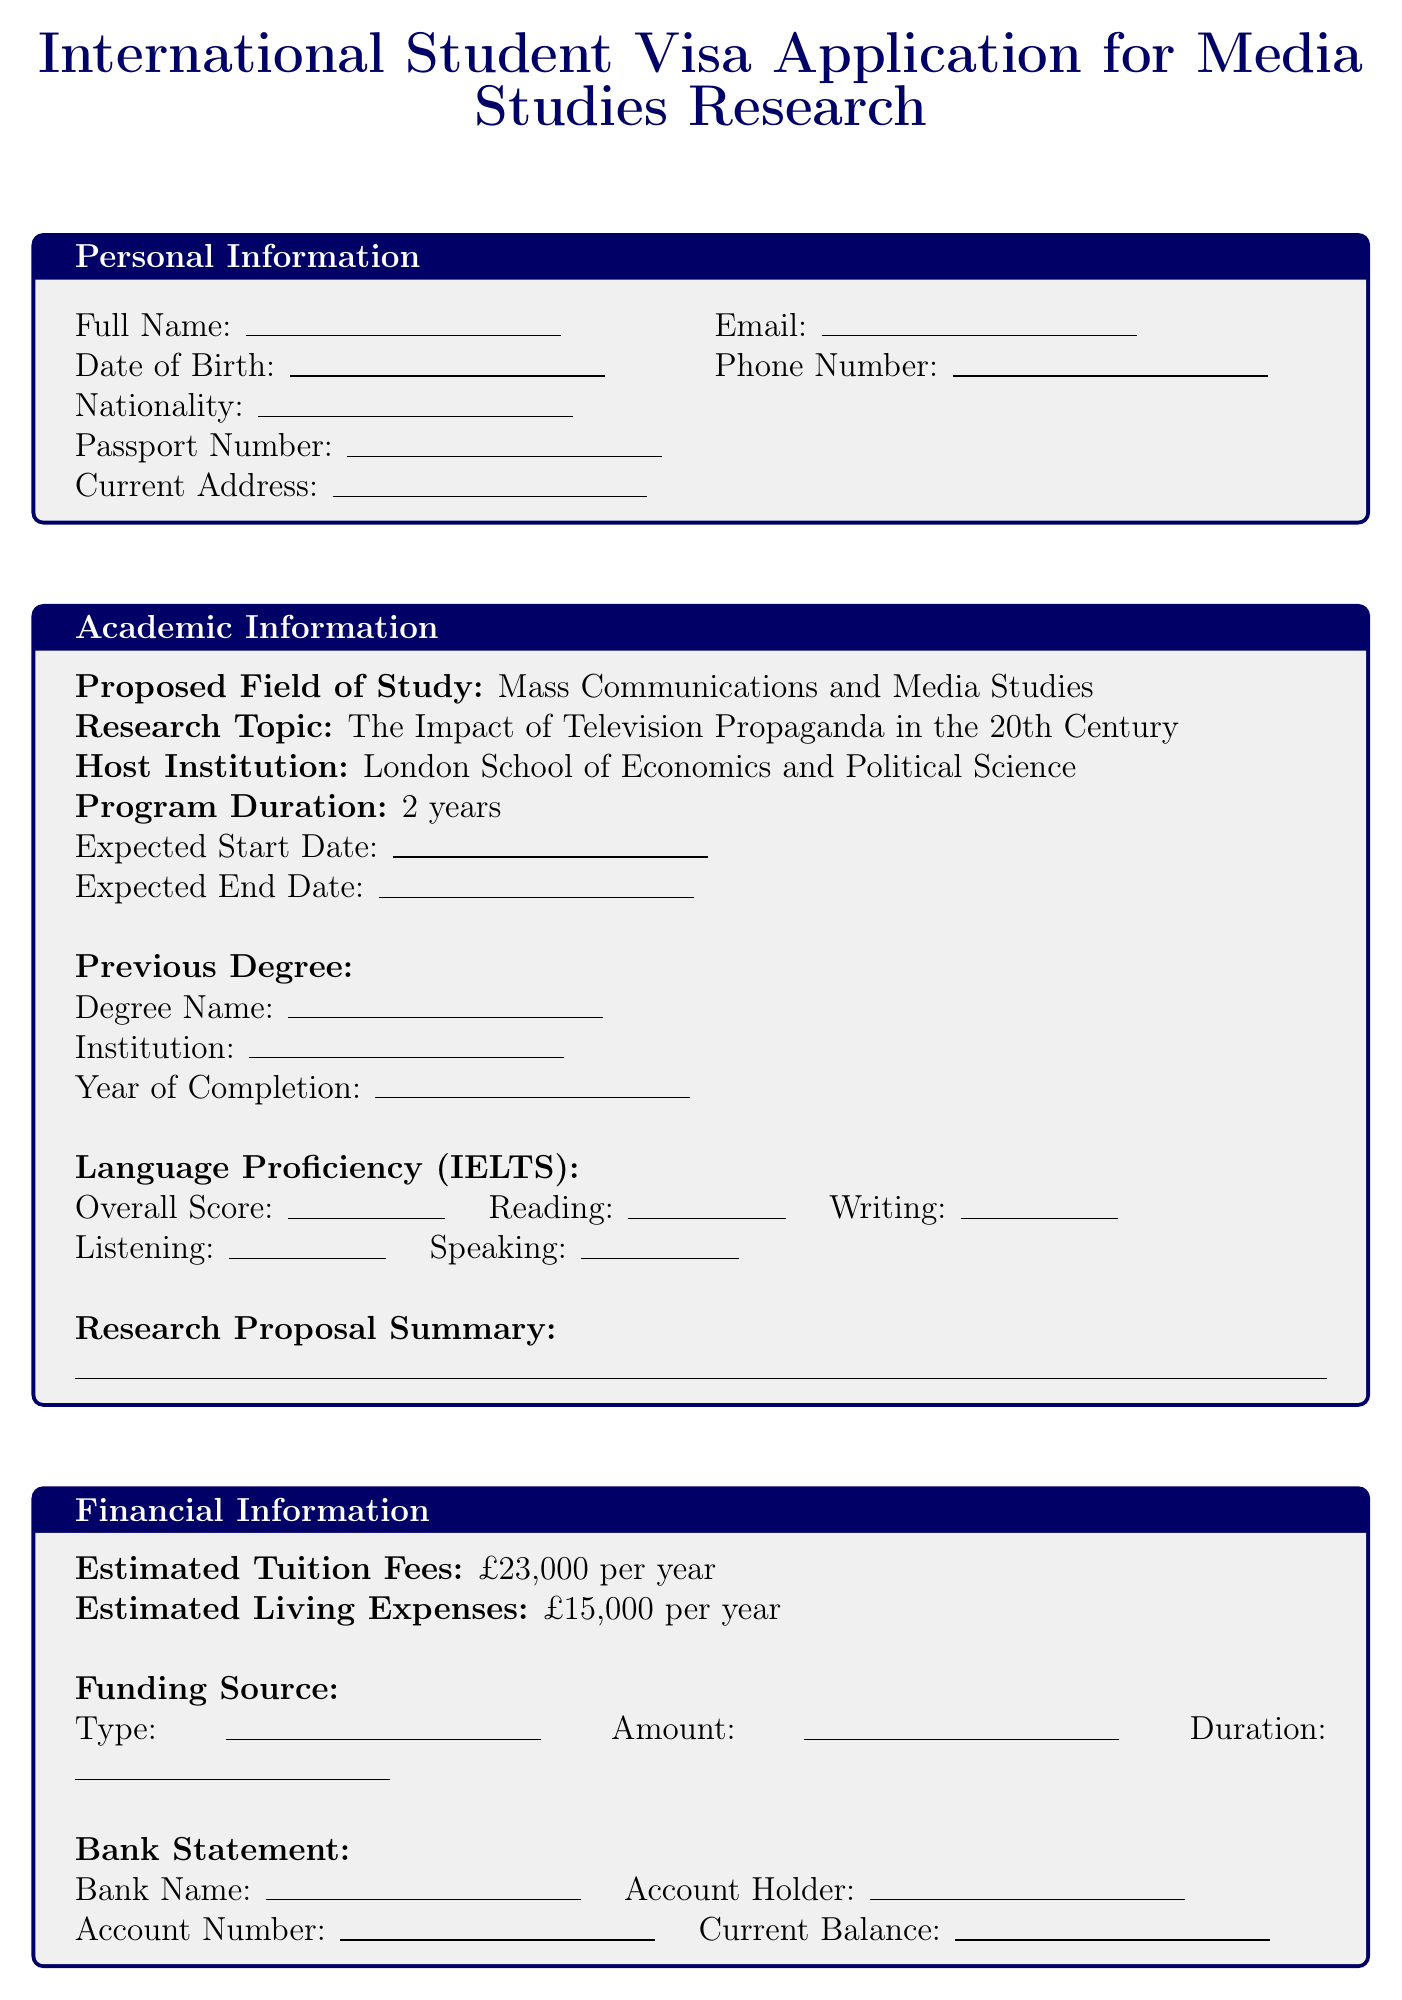what is the title of the document? The title is specified at the top of the rendered document, denoting the purpose and focus of the application.
Answer: International Student Visa Application for Media Studies Research who is the host institution for the proposed study? The host institution is indicated in the academic information section, showing where the student intends to study.
Answer: London School of Economics and Political Science what are the estimated tuition fees per year? The estimated tuition fees are clearly mentioned in the financial information section of the document.
Answer: £23,000 per year what is the proposed field of study? The proposed field of study is listed under the academic information section, detailing the student's area of focus.
Answer: Mass Communications and Media Studies how many years is the program duration? The program duration is specified and indicates how long the course will last.
Answer: 2 years who are the planned interview subjects? The document includes a list of individuals intended for interviews as part of the research.
Answer: Former television producers, Media historians, Political communication experts what is the IELTS overall score space size? The size reference for the IELTS overall score is indicated within the language proficiency section.
Answer: 2cm what type of visa is being applied for? The visa type is explicitly stated in the visa details section and is crucial for the application process.
Answer: Tier 4 (General) student visa which archives will be accessed for research? The document contains specific archives intended for research, listed only under research resources.
Answer: BBC Written Archives Centre, ITV Archives, British Film Institute National Archive 